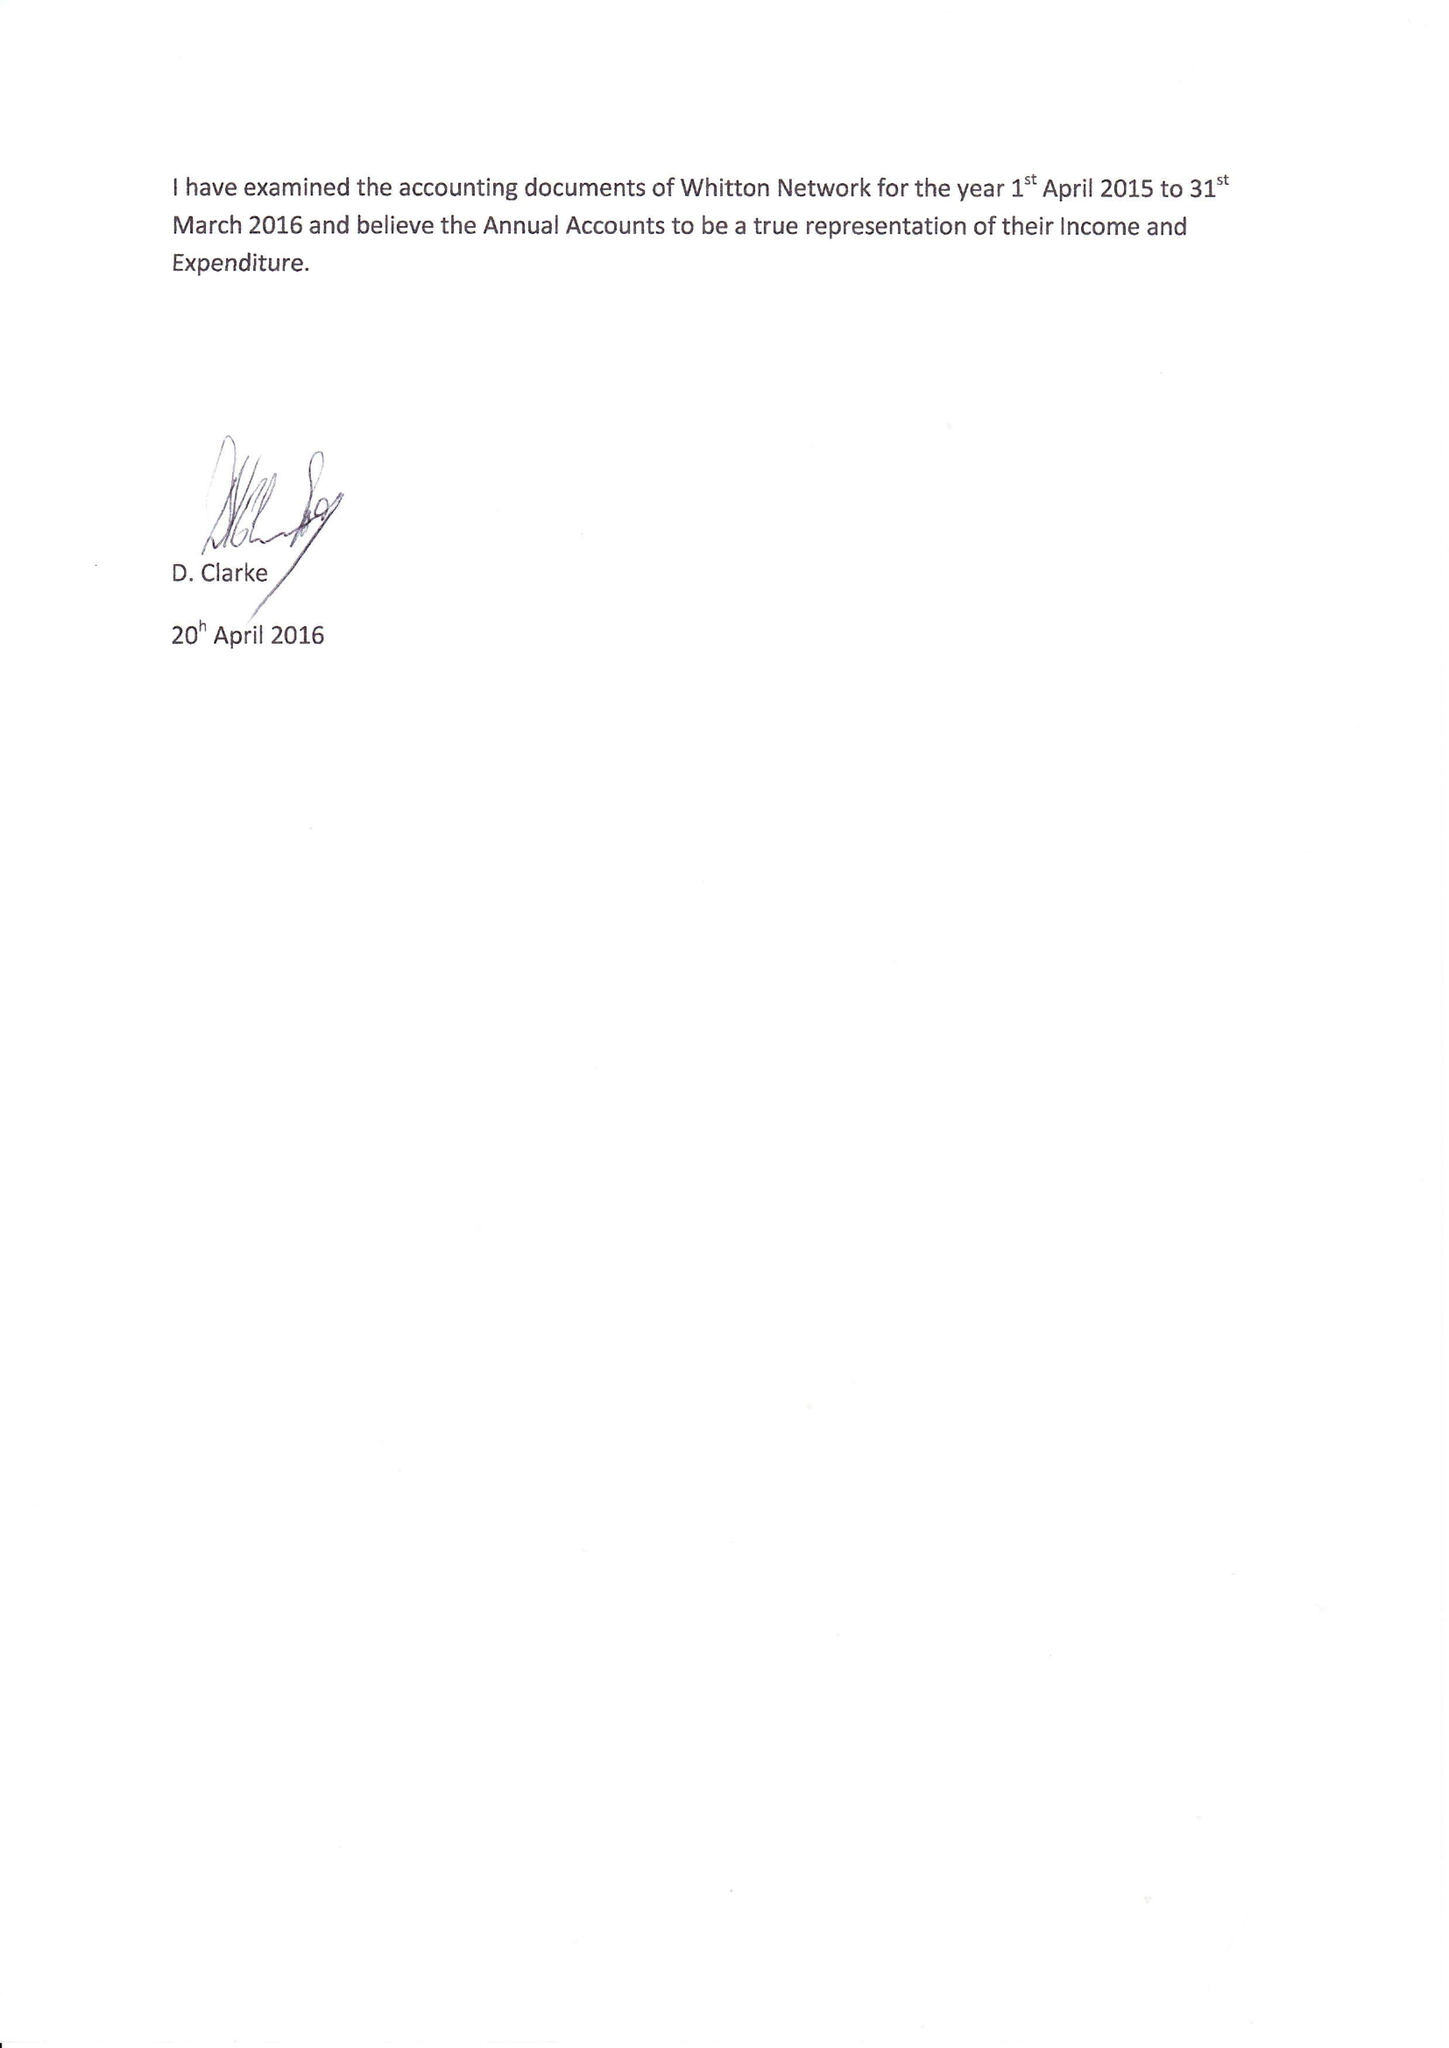What is the value for the report_date?
Answer the question using a single word or phrase. 2016-03-31 